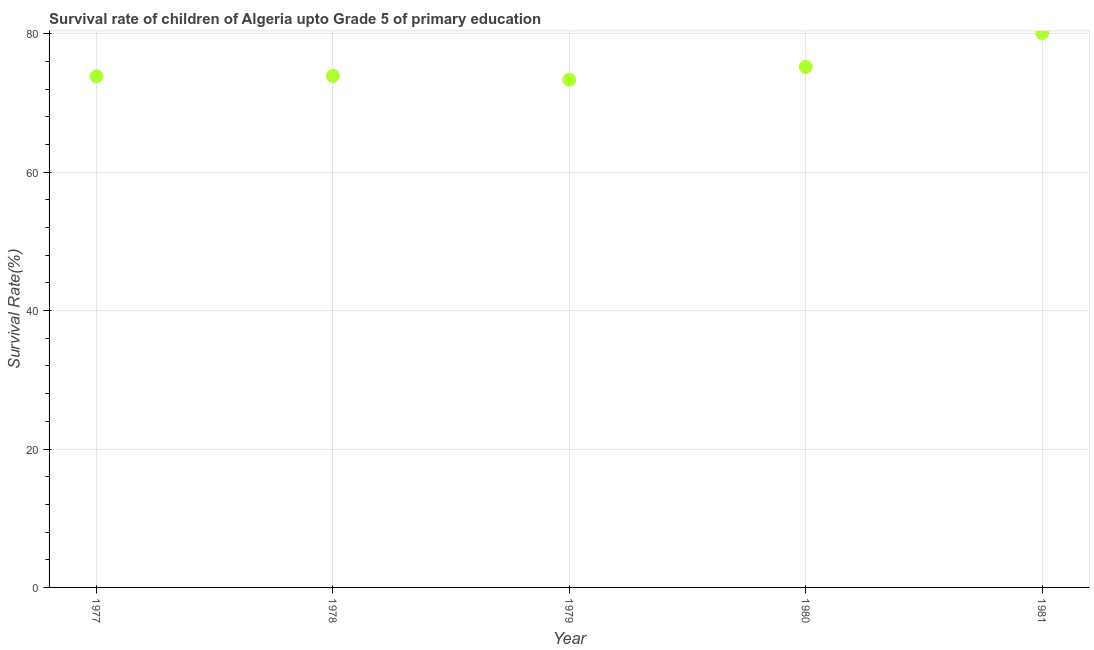What is the survival rate in 1979?
Keep it short and to the point. 73.37. Across all years, what is the maximum survival rate?
Give a very brief answer. 80.09. Across all years, what is the minimum survival rate?
Offer a terse response. 73.37. In which year was the survival rate maximum?
Your answer should be very brief. 1981. In which year was the survival rate minimum?
Keep it short and to the point. 1979. What is the sum of the survival rate?
Keep it short and to the point. 376.43. What is the difference between the survival rate in 1979 and 1980?
Provide a succinct answer. -1.85. What is the average survival rate per year?
Your response must be concise. 75.29. What is the median survival rate?
Offer a very short reply. 73.91. In how many years, is the survival rate greater than 32 %?
Ensure brevity in your answer.  5. What is the ratio of the survival rate in 1977 to that in 1978?
Provide a succinct answer. 1. Is the difference between the survival rate in 1977 and 1979 greater than the difference between any two years?
Give a very brief answer. No. What is the difference between the highest and the second highest survival rate?
Keep it short and to the point. 4.87. What is the difference between the highest and the lowest survival rate?
Your answer should be compact. 6.72. Does the survival rate monotonically increase over the years?
Give a very brief answer. No. Are the values on the major ticks of Y-axis written in scientific E-notation?
Your answer should be very brief. No. Does the graph contain any zero values?
Keep it short and to the point. No. Does the graph contain grids?
Provide a short and direct response. Yes. What is the title of the graph?
Your answer should be compact. Survival rate of children of Algeria upto Grade 5 of primary education. What is the label or title of the Y-axis?
Offer a very short reply. Survival Rate(%). What is the Survival Rate(%) in 1977?
Provide a succinct answer. 73.85. What is the Survival Rate(%) in 1978?
Make the answer very short. 73.91. What is the Survival Rate(%) in 1979?
Offer a terse response. 73.37. What is the Survival Rate(%) in 1980?
Provide a succinct answer. 75.21. What is the Survival Rate(%) in 1981?
Your response must be concise. 80.09. What is the difference between the Survival Rate(%) in 1977 and 1978?
Provide a succinct answer. -0.06. What is the difference between the Survival Rate(%) in 1977 and 1979?
Give a very brief answer. 0.48. What is the difference between the Survival Rate(%) in 1977 and 1980?
Provide a succinct answer. -1.36. What is the difference between the Survival Rate(%) in 1977 and 1981?
Your answer should be compact. -6.24. What is the difference between the Survival Rate(%) in 1978 and 1979?
Keep it short and to the point. 0.54. What is the difference between the Survival Rate(%) in 1978 and 1980?
Offer a terse response. -1.3. What is the difference between the Survival Rate(%) in 1978 and 1981?
Ensure brevity in your answer.  -6.17. What is the difference between the Survival Rate(%) in 1979 and 1980?
Provide a succinct answer. -1.85. What is the difference between the Survival Rate(%) in 1979 and 1981?
Give a very brief answer. -6.72. What is the difference between the Survival Rate(%) in 1980 and 1981?
Provide a short and direct response. -4.87. What is the ratio of the Survival Rate(%) in 1977 to that in 1978?
Offer a very short reply. 1. What is the ratio of the Survival Rate(%) in 1977 to that in 1981?
Your answer should be very brief. 0.92. What is the ratio of the Survival Rate(%) in 1978 to that in 1979?
Give a very brief answer. 1.01. What is the ratio of the Survival Rate(%) in 1978 to that in 1980?
Give a very brief answer. 0.98. What is the ratio of the Survival Rate(%) in 1978 to that in 1981?
Keep it short and to the point. 0.92. What is the ratio of the Survival Rate(%) in 1979 to that in 1981?
Offer a very short reply. 0.92. What is the ratio of the Survival Rate(%) in 1980 to that in 1981?
Keep it short and to the point. 0.94. 